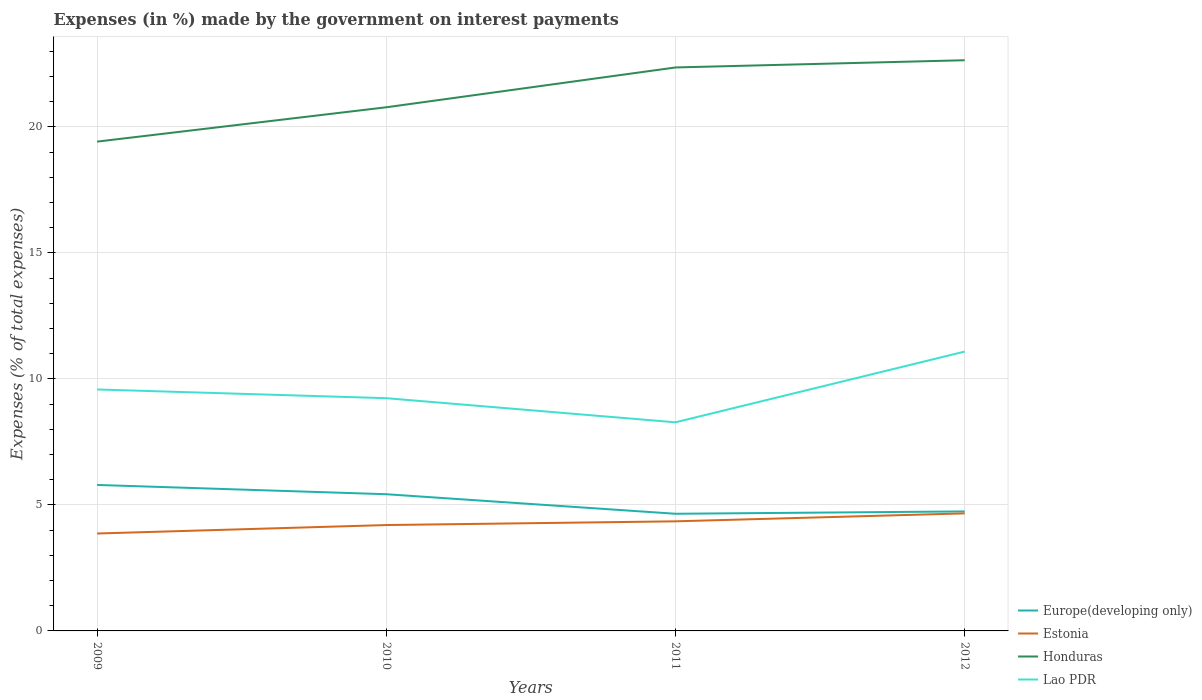Does the line corresponding to Estonia intersect with the line corresponding to Honduras?
Keep it short and to the point. No. Is the number of lines equal to the number of legend labels?
Offer a terse response. Yes. Across all years, what is the maximum percentage of expenses made by the government on interest payments in Estonia?
Your answer should be very brief. 3.87. In which year was the percentage of expenses made by the government on interest payments in Europe(developing only) maximum?
Give a very brief answer. 2011. What is the total percentage of expenses made by the government on interest payments in Lao PDR in the graph?
Offer a very short reply. 0.35. What is the difference between the highest and the second highest percentage of expenses made by the government on interest payments in Europe(developing only)?
Your answer should be very brief. 1.14. What is the difference between the highest and the lowest percentage of expenses made by the government on interest payments in Lao PDR?
Offer a very short reply. 2. How many lines are there?
Provide a short and direct response. 4. How many years are there in the graph?
Your answer should be compact. 4. Are the values on the major ticks of Y-axis written in scientific E-notation?
Make the answer very short. No. Does the graph contain any zero values?
Your answer should be compact. No. Does the graph contain grids?
Give a very brief answer. Yes. How many legend labels are there?
Give a very brief answer. 4. What is the title of the graph?
Your response must be concise. Expenses (in %) made by the government on interest payments. What is the label or title of the Y-axis?
Provide a short and direct response. Expenses (% of total expenses). What is the Expenses (% of total expenses) in Europe(developing only) in 2009?
Offer a terse response. 5.79. What is the Expenses (% of total expenses) of Estonia in 2009?
Offer a terse response. 3.87. What is the Expenses (% of total expenses) in Honduras in 2009?
Give a very brief answer. 19.42. What is the Expenses (% of total expenses) in Lao PDR in 2009?
Your response must be concise. 9.58. What is the Expenses (% of total expenses) in Europe(developing only) in 2010?
Ensure brevity in your answer.  5.42. What is the Expenses (% of total expenses) in Estonia in 2010?
Give a very brief answer. 4.2. What is the Expenses (% of total expenses) in Honduras in 2010?
Ensure brevity in your answer.  20.78. What is the Expenses (% of total expenses) in Lao PDR in 2010?
Your answer should be very brief. 9.23. What is the Expenses (% of total expenses) of Europe(developing only) in 2011?
Make the answer very short. 4.65. What is the Expenses (% of total expenses) of Estonia in 2011?
Your response must be concise. 4.35. What is the Expenses (% of total expenses) in Honduras in 2011?
Offer a terse response. 22.36. What is the Expenses (% of total expenses) of Lao PDR in 2011?
Provide a succinct answer. 8.28. What is the Expenses (% of total expenses) in Europe(developing only) in 2012?
Your answer should be compact. 4.74. What is the Expenses (% of total expenses) of Estonia in 2012?
Provide a short and direct response. 4.66. What is the Expenses (% of total expenses) in Honduras in 2012?
Offer a terse response. 22.64. What is the Expenses (% of total expenses) of Lao PDR in 2012?
Ensure brevity in your answer.  11.08. Across all years, what is the maximum Expenses (% of total expenses) in Europe(developing only)?
Offer a terse response. 5.79. Across all years, what is the maximum Expenses (% of total expenses) of Estonia?
Offer a very short reply. 4.66. Across all years, what is the maximum Expenses (% of total expenses) in Honduras?
Your response must be concise. 22.64. Across all years, what is the maximum Expenses (% of total expenses) in Lao PDR?
Provide a succinct answer. 11.08. Across all years, what is the minimum Expenses (% of total expenses) in Europe(developing only)?
Your answer should be compact. 4.65. Across all years, what is the minimum Expenses (% of total expenses) of Estonia?
Your answer should be very brief. 3.87. Across all years, what is the minimum Expenses (% of total expenses) of Honduras?
Your answer should be compact. 19.42. Across all years, what is the minimum Expenses (% of total expenses) in Lao PDR?
Provide a succinct answer. 8.28. What is the total Expenses (% of total expenses) in Europe(developing only) in the graph?
Make the answer very short. 20.61. What is the total Expenses (% of total expenses) of Estonia in the graph?
Your answer should be very brief. 17.08. What is the total Expenses (% of total expenses) in Honduras in the graph?
Your response must be concise. 85.2. What is the total Expenses (% of total expenses) of Lao PDR in the graph?
Your answer should be compact. 38.18. What is the difference between the Expenses (% of total expenses) in Europe(developing only) in 2009 and that in 2010?
Offer a very short reply. 0.37. What is the difference between the Expenses (% of total expenses) of Estonia in 2009 and that in 2010?
Keep it short and to the point. -0.34. What is the difference between the Expenses (% of total expenses) of Honduras in 2009 and that in 2010?
Provide a succinct answer. -1.36. What is the difference between the Expenses (% of total expenses) in Lao PDR in 2009 and that in 2010?
Ensure brevity in your answer.  0.35. What is the difference between the Expenses (% of total expenses) of Europe(developing only) in 2009 and that in 2011?
Your response must be concise. 1.14. What is the difference between the Expenses (% of total expenses) of Estonia in 2009 and that in 2011?
Your answer should be very brief. -0.48. What is the difference between the Expenses (% of total expenses) of Honduras in 2009 and that in 2011?
Make the answer very short. -2.94. What is the difference between the Expenses (% of total expenses) in Lao PDR in 2009 and that in 2011?
Ensure brevity in your answer.  1.3. What is the difference between the Expenses (% of total expenses) of Europe(developing only) in 2009 and that in 2012?
Ensure brevity in your answer.  1.05. What is the difference between the Expenses (% of total expenses) in Estonia in 2009 and that in 2012?
Provide a short and direct response. -0.8. What is the difference between the Expenses (% of total expenses) of Honduras in 2009 and that in 2012?
Give a very brief answer. -3.23. What is the difference between the Expenses (% of total expenses) of Lao PDR in 2009 and that in 2012?
Your answer should be compact. -1.5. What is the difference between the Expenses (% of total expenses) of Europe(developing only) in 2010 and that in 2011?
Ensure brevity in your answer.  0.78. What is the difference between the Expenses (% of total expenses) of Estonia in 2010 and that in 2011?
Provide a succinct answer. -0.15. What is the difference between the Expenses (% of total expenses) of Honduras in 2010 and that in 2011?
Your response must be concise. -1.58. What is the difference between the Expenses (% of total expenses) of Europe(developing only) in 2010 and that in 2012?
Your response must be concise. 0.68. What is the difference between the Expenses (% of total expenses) in Estonia in 2010 and that in 2012?
Offer a very short reply. -0.46. What is the difference between the Expenses (% of total expenses) of Honduras in 2010 and that in 2012?
Ensure brevity in your answer.  -1.87. What is the difference between the Expenses (% of total expenses) of Lao PDR in 2010 and that in 2012?
Ensure brevity in your answer.  -1.85. What is the difference between the Expenses (% of total expenses) of Europe(developing only) in 2011 and that in 2012?
Your answer should be very brief. -0.09. What is the difference between the Expenses (% of total expenses) of Estonia in 2011 and that in 2012?
Your answer should be very brief. -0.32. What is the difference between the Expenses (% of total expenses) of Honduras in 2011 and that in 2012?
Provide a short and direct response. -0.29. What is the difference between the Expenses (% of total expenses) of Lao PDR in 2011 and that in 2012?
Make the answer very short. -2.81. What is the difference between the Expenses (% of total expenses) in Europe(developing only) in 2009 and the Expenses (% of total expenses) in Estonia in 2010?
Ensure brevity in your answer.  1.59. What is the difference between the Expenses (% of total expenses) of Europe(developing only) in 2009 and the Expenses (% of total expenses) of Honduras in 2010?
Give a very brief answer. -14.99. What is the difference between the Expenses (% of total expenses) of Europe(developing only) in 2009 and the Expenses (% of total expenses) of Lao PDR in 2010?
Offer a terse response. -3.44. What is the difference between the Expenses (% of total expenses) in Estonia in 2009 and the Expenses (% of total expenses) in Honduras in 2010?
Your response must be concise. -16.91. What is the difference between the Expenses (% of total expenses) in Estonia in 2009 and the Expenses (% of total expenses) in Lao PDR in 2010?
Provide a short and direct response. -5.37. What is the difference between the Expenses (% of total expenses) of Honduras in 2009 and the Expenses (% of total expenses) of Lao PDR in 2010?
Make the answer very short. 10.18. What is the difference between the Expenses (% of total expenses) in Europe(developing only) in 2009 and the Expenses (% of total expenses) in Estonia in 2011?
Your response must be concise. 1.44. What is the difference between the Expenses (% of total expenses) in Europe(developing only) in 2009 and the Expenses (% of total expenses) in Honduras in 2011?
Your answer should be very brief. -16.57. What is the difference between the Expenses (% of total expenses) of Europe(developing only) in 2009 and the Expenses (% of total expenses) of Lao PDR in 2011?
Provide a short and direct response. -2.49. What is the difference between the Expenses (% of total expenses) in Estonia in 2009 and the Expenses (% of total expenses) in Honduras in 2011?
Keep it short and to the point. -18.49. What is the difference between the Expenses (% of total expenses) of Estonia in 2009 and the Expenses (% of total expenses) of Lao PDR in 2011?
Offer a terse response. -4.41. What is the difference between the Expenses (% of total expenses) in Honduras in 2009 and the Expenses (% of total expenses) in Lao PDR in 2011?
Your answer should be very brief. 11.14. What is the difference between the Expenses (% of total expenses) of Europe(developing only) in 2009 and the Expenses (% of total expenses) of Estonia in 2012?
Offer a terse response. 1.13. What is the difference between the Expenses (% of total expenses) of Europe(developing only) in 2009 and the Expenses (% of total expenses) of Honduras in 2012?
Provide a succinct answer. -16.85. What is the difference between the Expenses (% of total expenses) in Europe(developing only) in 2009 and the Expenses (% of total expenses) in Lao PDR in 2012?
Your response must be concise. -5.29. What is the difference between the Expenses (% of total expenses) in Estonia in 2009 and the Expenses (% of total expenses) in Honduras in 2012?
Provide a succinct answer. -18.78. What is the difference between the Expenses (% of total expenses) of Estonia in 2009 and the Expenses (% of total expenses) of Lao PDR in 2012?
Give a very brief answer. -7.22. What is the difference between the Expenses (% of total expenses) of Honduras in 2009 and the Expenses (% of total expenses) of Lao PDR in 2012?
Give a very brief answer. 8.33. What is the difference between the Expenses (% of total expenses) of Europe(developing only) in 2010 and the Expenses (% of total expenses) of Estonia in 2011?
Provide a short and direct response. 1.08. What is the difference between the Expenses (% of total expenses) in Europe(developing only) in 2010 and the Expenses (% of total expenses) in Honduras in 2011?
Your answer should be compact. -16.93. What is the difference between the Expenses (% of total expenses) in Europe(developing only) in 2010 and the Expenses (% of total expenses) in Lao PDR in 2011?
Your answer should be compact. -2.85. What is the difference between the Expenses (% of total expenses) of Estonia in 2010 and the Expenses (% of total expenses) of Honduras in 2011?
Offer a very short reply. -18.16. What is the difference between the Expenses (% of total expenses) in Estonia in 2010 and the Expenses (% of total expenses) in Lao PDR in 2011?
Offer a very short reply. -4.08. What is the difference between the Expenses (% of total expenses) of Honduras in 2010 and the Expenses (% of total expenses) of Lao PDR in 2011?
Make the answer very short. 12.5. What is the difference between the Expenses (% of total expenses) of Europe(developing only) in 2010 and the Expenses (% of total expenses) of Estonia in 2012?
Offer a very short reply. 0.76. What is the difference between the Expenses (% of total expenses) in Europe(developing only) in 2010 and the Expenses (% of total expenses) in Honduras in 2012?
Provide a succinct answer. -17.22. What is the difference between the Expenses (% of total expenses) in Europe(developing only) in 2010 and the Expenses (% of total expenses) in Lao PDR in 2012?
Your answer should be compact. -5.66. What is the difference between the Expenses (% of total expenses) in Estonia in 2010 and the Expenses (% of total expenses) in Honduras in 2012?
Offer a very short reply. -18.44. What is the difference between the Expenses (% of total expenses) of Estonia in 2010 and the Expenses (% of total expenses) of Lao PDR in 2012?
Your answer should be very brief. -6.88. What is the difference between the Expenses (% of total expenses) in Honduras in 2010 and the Expenses (% of total expenses) in Lao PDR in 2012?
Your response must be concise. 9.69. What is the difference between the Expenses (% of total expenses) in Europe(developing only) in 2011 and the Expenses (% of total expenses) in Estonia in 2012?
Keep it short and to the point. -0.02. What is the difference between the Expenses (% of total expenses) in Europe(developing only) in 2011 and the Expenses (% of total expenses) in Honduras in 2012?
Your answer should be compact. -18. What is the difference between the Expenses (% of total expenses) of Europe(developing only) in 2011 and the Expenses (% of total expenses) of Lao PDR in 2012?
Your response must be concise. -6.44. What is the difference between the Expenses (% of total expenses) of Estonia in 2011 and the Expenses (% of total expenses) of Honduras in 2012?
Your answer should be very brief. -18.3. What is the difference between the Expenses (% of total expenses) in Estonia in 2011 and the Expenses (% of total expenses) in Lao PDR in 2012?
Keep it short and to the point. -6.74. What is the difference between the Expenses (% of total expenses) of Honduras in 2011 and the Expenses (% of total expenses) of Lao PDR in 2012?
Make the answer very short. 11.27. What is the average Expenses (% of total expenses) in Europe(developing only) per year?
Offer a very short reply. 5.15. What is the average Expenses (% of total expenses) of Estonia per year?
Your response must be concise. 4.27. What is the average Expenses (% of total expenses) of Honduras per year?
Provide a short and direct response. 21.3. What is the average Expenses (% of total expenses) in Lao PDR per year?
Your response must be concise. 9.54. In the year 2009, what is the difference between the Expenses (% of total expenses) of Europe(developing only) and Expenses (% of total expenses) of Estonia?
Offer a very short reply. 1.93. In the year 2009, what is the difference between the Expenses (% of total expenses) of Europe(developing only) and Expenses (% of total expenses) of Honduras?
Ensure brevity in your answer.  -13.62. In the year 2009, what is the difference between the Expenses (% of total expenses) in Europe(developing only) and Expenses (% of total expenses) in Lao PDR?
Your answer should be compact. -3.79. In the year 2009, what is the difference between the Expenses (% of total expenses) of Estonia and Expenses (% of total expenses) of Honduras?
Your answer should be very brief. -15.55. In the year 2009, what is the difference between the Expenses (% of total expenses) in Estonia and Expenses (% of total expenses) in Lao PDR?
Offer a very short reply. -5.72. In the year 2009, what is the difference between the Expenses (% of total expenses) in Honduras and Expenses (% of total expenses) in Lao PDR?
Keep it short and to the point. 9.83. In the year 2010, what is the difference between the Expenses (% of total expenses) of Europe(developing only) and Expenses (% of total expenses) of Estonia?
Offer a terse response. 1.22. In the year 2010, what is the difference between the Expenses (% of total expenses) in Europe(developing only) and Expenses (% of total expenses) in Honduras?
Offer a terse response. -15.35. In the year 2010, what is the difference between the Expenses (% of total expenses) in Europe(developing only) and Expenses (% of total expenses) in Lao PDR?
Provide a succinct answer. -3.81. In the year 2010, what is the difference between the Expenses (% of total expenses) of Estonia and Expenses (% of total expenses) of Honduras?
Offer a very short reply. -16.58. In the year 2010, what is the difference between the Expenses (% of total expenses) in Estonia and Expenses (% of total expenses) in Lao PDR?
Your response must be concise. -5.03. In the year 2010, what is the difference between the Expenses (% of total expenses) of Honduras and Expenses (% of total expenses) of Lao PDR?
Your answer should be compact. 11.54. In the year 2011, what is the difference between the Expenses (% of total expenses) in Europe(developing only) and Expenses (% of total expenses) in Estonia?
Your answer should be very brief. 0.3. In the year 2011, what is the difference between the Expenses (% of total expenses) in Europe(developing only) and Expenses (% of total expenses) in Honduras?
Your answer should be compact. -17.71. In the year 2011, what is the difference between the Expenses (% of total expenses) in Europe(developing only) and Expenses (% of total expenses) in Lao PDR?
Ensure brevity in your answer.  -3.63. In the year 2011, what is the difference between the Expenses (% of total expenses) in Estonia and Expenses (% of total expenses) in Honduras?
Make the answer very short. -18.01. In the year 2011, what is the difference between the Expenses (% of total expenses) in Estonia and Expenses (% of total expenses) in Lao PDR?
Make the answer very short. -3.93. In the year 2011, what is the difference between the Expenses (% of total expenses) in Honduras and Expenses (% of total expenses) in Lao PDR?
Your answer should be very brief. 14.08. In the year 2012, what is the difference between the Expenses (% of total expenses) of Europe(developing only) and Expenses (% of total expenses) of Estonia?
Your response must be concise. 0.08. In the year 2012, what is the difference between the Expenses (% of total expenses) in Europe(developing only) and Expenses (% of total expenses) in Honduras?
Keep it short and to the point. -17.9. In the year 2012, what is the difference between the Expenses (% of total expenses) of Europe(developing only) and Expenses (% of total expenses) of Lao PDR?
Give a very brief answer. -6.34. In the year 2012, what is the difference between the Expenses (% of total expenses) in Estonia and Expenses (% of total expenses) in Honduras?
Make the answer very short. -17.98. In the year 2012, what is the difference between the Expenses (% of total expenses) in Estonia and Expenses (% of total expenses) in Lao PDR?
Keep it short and to the point. -6.42. In the year 2012, what is the difference between the Expenses (% of total expenses) in Honduras and Expenses (% of total expenses) in Lao PDR?
Your answer should be compact. 11.56. What is the ratio of the Expenses (% of total expenses) in Europe(developing only) in 2009 to that in 2010?
Offer a terse response. 1.07. What is the ratio of the Expenses (% of total expenses) in Estonia in 2009 to that in 2010?
Your answer should be very brief. 0.92. What is the ratio of the Expenses (% of total expenses) of Honduras in 2009 to that in 2010?
Give a very brief answer. 0.93. What is the ratio of the Expenses (% of total expenses) in Lao PDR in 2009 to that in 2010?
Give a very brief answer. 1.04. What is the ratio of the Expenses (% of total expenses) in Europe(developing only) in 2009 to that in 2011?
Provide a succinct answer. 1.25. What is the ratio of the Expenses (% of total expenses) of Estonia in 2009 to that in 2011?
Offer a very short reply. 0.89. What is the ratio of the Expenses (% of total expenses) in Honduras in 2009 to that in 2011?
Make the answer very short. 0.87. What is the ratio of the Expenses (% of total expenses) in Lao PDR in 2009 to that in 2011?
Make the answer very short. 1.16. What is the ratio of the Expenses (% of total expenses) of Europe(developing only) in 2009 to that in 2012?
Ensure brevity in your answer.  1.22. What is the ratio of the Expenses (% of total expenses) of Estonia in 2009 to that in 2012?
Keep it short and to the point. 0.83. What is the ratio of the Expenses (% of total expenses) of Honduras in 2009 to that in 2012?
Offer a terse response. 0.86. What is the ratio of the Expenses (% of total expenses) of Lao PDR in 2009 to that in 2012?
Provide a short and direct response. 0.86. What is the ratio of the Expenses (% of total expenses) of Europe(developing only) in 2010 to that in 2011?
Offer a very short reply. 1.17. What is the ratio of the Expenses (% of total expenses) in Estonia in 2010 to that in 2011?
Provide a short and direct response. 0.97. What is the ratio of the Expenses (% of total expenses) of Honduras in 2010 to that in 2011?
Your answer should be compact. 0.93. What is the ratio of the Expenses (% of total expenses) of Lao PDR in 2010 to that in 2011?
Ensure brevity in your answer.  1.12. What is the ratio of the Expenses (% of total expenses) in Europe(developing only) in 2010 to that in 2012?
Ensure brevity in your answer.  1.14. What is the ratio of the Expenses (% of total expenses) of Estonia in 2010 to that in 2012?
Your answer should be compact. 0.9. What is the ratio of the Expenses (% of total expenses) in Honduras in 2010 to that in 2012?
Provide a short and direct response. 0.92. What is the ratio of the Expenses (% of total expenses) in Lao PDR in 2010 to that in 2012?
Make the answer very short. 0.83. What is the ratio of the Expenses (% of total expenses) of Europe(developing only) in 2011 to that in 2012?
Offer a very short reply. 0.98. What is the ratio of the Expenses (% of total expenses) in Estonia in 2011 to that in 2012?
Provide a short and direct response. 0.93. What is the ratio of the Expenses (% of total expenses) in Honduras in 2011 to that in 2012?
Ensure brevity in your answer.  0.99. What is the ratio of the Expenses (% of total expenses) of Lao PDR in 2011 to that in 2012?
Keep it short and to the point. 0.75. What is the difference between the highest and the second highest Expenses (% of total expenses) of Europe(developing only)?
Ensure brevity in your answer.  0.37. What is the difference between the highest and the second highest Expenses (% of total expenses) of Estonia?
Offer a very short reply. 0.32. What is the difference between the highest and the second highest Expenses (% of total expenses) of Honduras?
Keep it short and to the point. 0.29. What is the difference between the highest and the second highest Expenses (% of total expenses) in Lao PDR?
Ensure brevity in your answer.  1.5. What is the difference between the highest and the lowest Expenses (% of total expenses) of Europe(developing only)?
Your answer should be very brief. 1.14. What is the difference between the highest and the lowest Expenses (% of total expenses) in Estonia?
Keep it short and to the point. 0.8. What is the difference between the highest and the lowest Expenses (% of total expenses) in Honduras?
Provide a succinct answer. 3.23. What is the difference between the highest and the lowest Expenses (% of total expenses) of Lao PDR?
Ensure brevity in your answer.  2.81. 